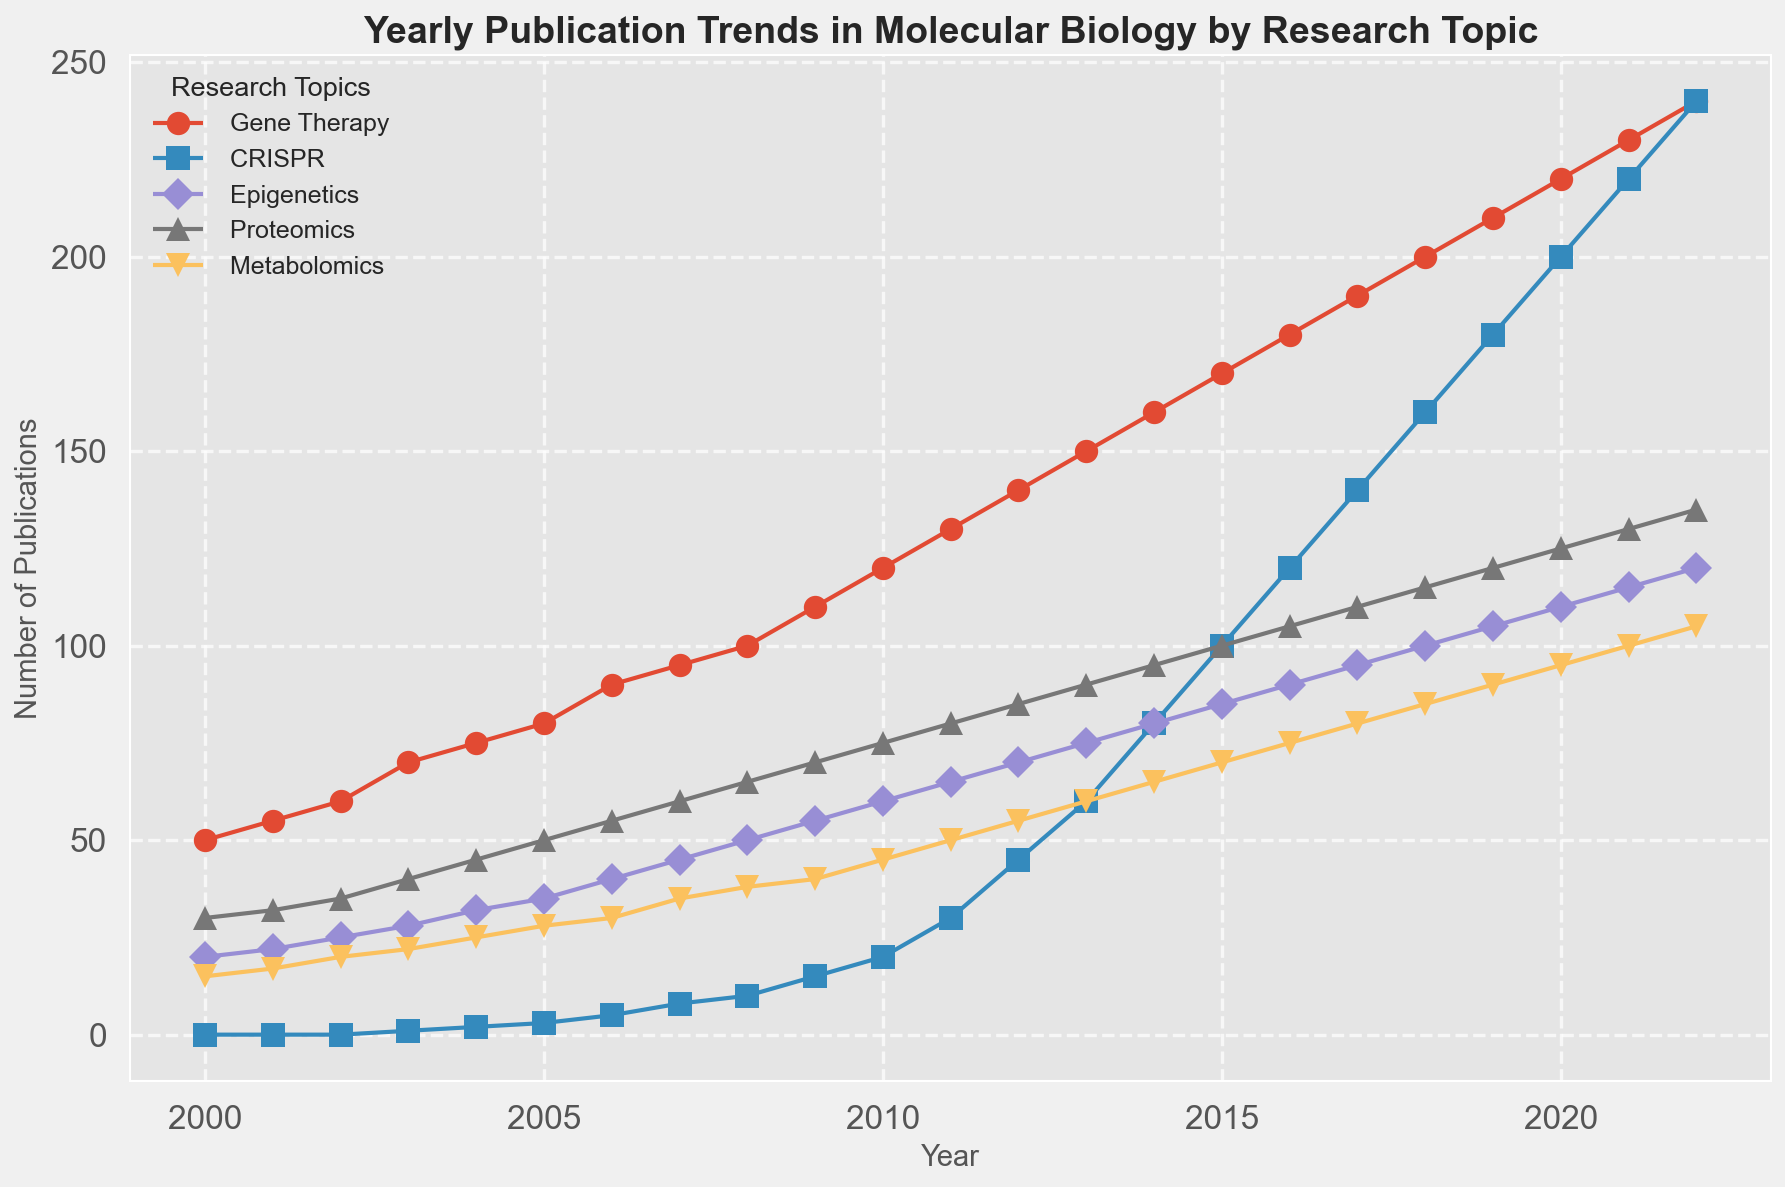What research topic had zero publications in 2000? By looking at the start of the plot for 2000, we see 'Gene Therapy' starting at 50, 'CRISPR' at 0, 'Epigenetics' at 20, 'Proteomics' at 30, and 'Metabolomics' at 15. So, CRISPR had zero publications.
Answer: CRISPR Which topic experienced the steepest rise in publications between 2010 and 2020? To determine this, observe the slopes of the lines for each topic from 2010 to 2020. 'Gene Therapy' progresses from 120 to 220, 'CRISPR' moves from 20 to 200, 'Epigenetics' from 60 to 110, 'Proteomics' from 75 to 125, and 'Metabolomics' from 45 to 95. The steepest rise is in 'CRISPR' (180 publications increase).
Answer: CRISPR What was the total number of publications for Gene Therapy, CRISPR, and Epigenetics in 2015? Add the values for 'Gene Therapy', 'CRISPR', and 'Epigenetics' for the year 2015: Gene Therapy (170) + CRISPR (100) + Epigenetics (85) = 355.
Answer: 355 Which research topic had equal publications in 2020 and 2021, and what was the number? By looking at the plot, check if any line stays horizontal between 2020 and 2021. 'CRISPR' stays at 220 publications both years.
Answer: CRISPR, 220 What visual clue indicates the fastest-growing topic in molecular biology after 2010? The fastest-growing topic will show the steepest upward line slope visually. 'CRISPR' stands out as having the steepest slope after 2010, indicating rapid growth.
Answer: Steep upward slope Between 2006 and 2012, which topic shows the least growth in the number of publications? By comparing the vertical rise of each line between 2006 and 2012: 'Gene Therapy' rises from 90 to 140 (50 publications), 'CRISPR' from 5 to 45 (40), 'Epigenetics' from 40 to 70 (30), 'Proteomics' from 55 to 85 (30), and 'Metabolomics' from 30 to 55 (25). Metabolomics has the least growth.
Answer: Metabolomics How do the publication trends in Proteomics compare from 2000 to 2022 in terms of growth? Visually track the 'Proteomics' line from 2000 to 2022, noting consistent and steady upward growth from 30 to 135 publications, indicating steady interest and increasing publications over the period.
Answer: Steady upward growth If we were to predict trends, which topic is most likely to surpass Gene Therapy in publications by 2025? By extending the trends visually, 'CRISPR' shows a trajectory that could exceed 'Gene Therapy' publications by 2025 based on its sharp and consistent upward trend.
Answer: CRISPR What is the combined number of publications for Epigenetics and Metabolomics in 2022? Sum the values for 2022: Epigenetics (120) + Metabolomics (105) = 225.
Answer: 225 